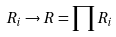Convert formula to latex. <formula><loc_0><loc_0><loc_500><loc_500>R _ { i } \rightarrow R = \prod R _ { i }</formula> 